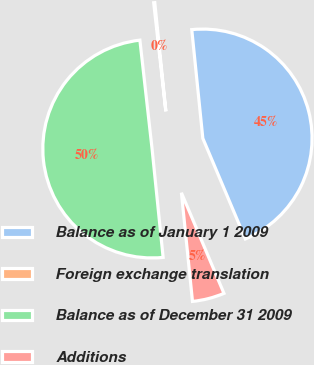Convert chart. <chart><loc_0><loc_0><loc_500><loc_500><pie_chart><fcel>Balance as of January 1 2009<fcel>Foreign exchange translation<fcel>Balance as of December 31 2009<fcel>Additions<nl><fcel>45.25%<fcel>0.16%<fcel>49.84%<fcel>4.75%<nl></chart> 